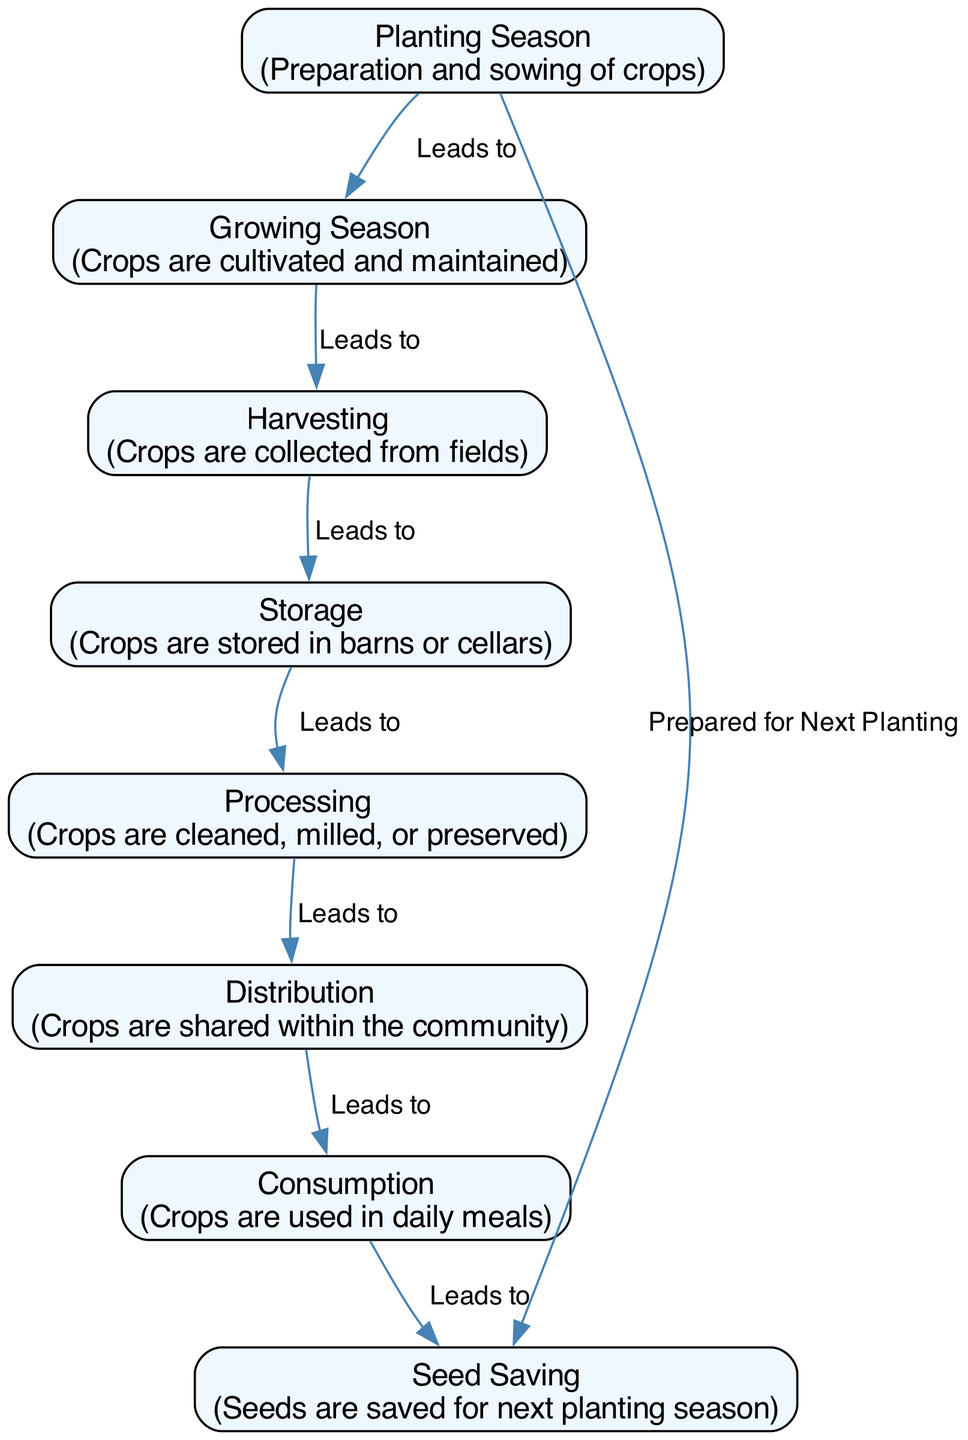What is the first step in the crop cycle? The diagram starts with the "Planting Season," which indicates the initial phase where preparation and sowing of crops occur.
Answer: Planting Season How many nodes are present in the diagram? The diagram contains a total of eight nodes representing different stages in the crop cycle.
Answer: Eight What follows the Harvesting step? The diagram shows that after the "Harvesting" step, the next stage is "Storage," where crops are stored in barns or cellars.
Answer: Storage Which step leads to Consumption? The path goes from "Distribution" to "Consumption," meaning the crops shared within the community are subsequently used in daily meals.
Answer: Distribution What is the relationship between Processing and Storage? The edge from "Storage" to "Processing" indicates that crops are processed only after they have been stored, fulfilling the necessary steps of storage first.
Answer: Leads to What is saved for the next planting season? The final step leads to "Seed Saving," indicating that seeds are preserved from the harvested crops for the subsequent planting season.
Answer: Seeds How many edges are there that connect the nodes? Upon reviewing the diagram, there are seven edges representing the connections between the nodes and the flow of the crop cycle.
Answer: Seven What phase comes directly after the Growing Season? According to the flow of the diagram, the phase that follows the "Growing Season" is "Harvesting," where crops are collected from the fields.
Answer: Harvesting What is the last step in the cycle before returning to the beginning? The last designated step in the cycle before going back to the initial phase of planting is "Seed Saving," indicating the process for preparing future crops.
Answer: Seed Saving 